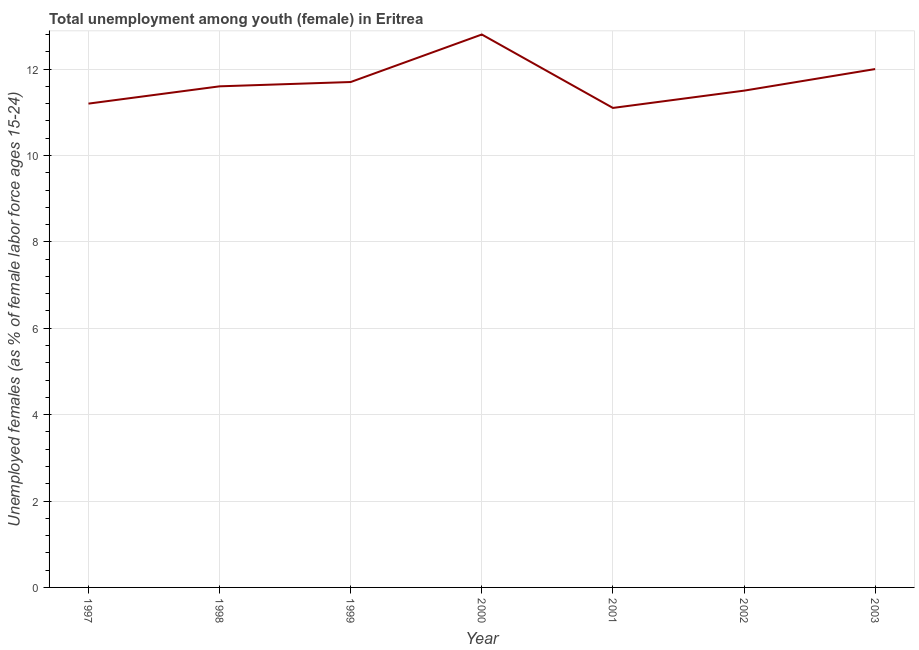What is the unemployed female youth population in 1999?
Keep it short and to the point. 11.7. Across all years, what is the maximum unemployed female youth population?
Keep it short and to the point. 12.8. Across all years, what is the minimum unemployed female youth population?
Keep it short and to the point. 11.1. In which year was the unemployed female youth population maximum?
Keep it short and to the point. 2000. In which year was the unemployed female youth population minimum?
Your response must be concise. 2001. What is the sum of the unemployed female youth population?
Offer a very short reply. 81.9. What is the difference between the unemployed female youth population in 2000 and 2003?
Your answer should be very brief. 0.8. What is the average unemployed female youth population per year?
Ensure brevity in your answer.  11.7. What is the median unemployed female youth population?
Provide a short and direct response. 11.6. In how many years, is the unemployed female youth population greater than 4 %?
Your answer should be very brief. 7. What is the ratio of the unemployed female youth population in 2000 to that in 2001?
Provide a succinct answer. 1.15. Is the unemployed female youth population in 2000 less than that in 2003?
Provide a succinct answer. No. What is the difference between the highest and the second highest unemployed female youth population?
Your answer should be very brief. 0.8. What is the difference between the highest and the lowest unemployed female youth population?
Offer a terse response. 1.7. In how many years, is the unemployed female youth population greater than the average unemployed female youth population taken over all years?
Provide a short and direct response. 2. Does the unemployed female youth population monotonically increase over the years?
Keep it short and to the point. No. How many lines are there?
Provide a short and direct response. 1. How many years are there in the graph?
Make the answer very short. 7. What is the difference between two consecutive major ticks on the Y-axis?
Make the answer very short. 2. Does the graph contain any zero values?
Your answer should be very brief. No. Does the graph contain grids?
Make the answer very short. Yes. What is the title of the graph?
Your response must be concise. Total unemployment among youth (female) in Eritrea. What is the label or title of the X-axis?
Ensure brevity in your answer.  Year. What is the label or title of the Y-axis?
Give a very brief answer. Unemployed females (as % of female labor force ages 15-24). What is the Unemployed females (as % of female labor force ages 15-24) of 1997?
Give a very brief answer. 11.2. What is the Unemployed females (as % of female labor force ages 15-24) of 1998?
Your response must be concise. 11.6. What is the Unemployed females (as % of female labor force ages 15-24) in 1999?
Provide a succinct answer. 11.7. What is the Unemployed females (as % of female labor force ages 15-24) in 2000?
Offer a terse response. 12.8. What is the Unemployed females (as % of female labor force ages 15-24) in 2001?
Give a very brief answer. 11.1. What is the difference between the Unemployed females (as % of female labor force ages 15-24) in 1997 and 1998?
Offer a very short reply. -0.4. What is the difference between the Unemployed females (as % of female labor force ages 15-24) in 1997 and 1999?
Give a very brief answer. -0.5. What is the difference between the Unemployed females (as % of female labor force ages 15-24) in 1997 and 2000?
Your answer should be compact. -1.6. What is the difference between the Unemployed females (as % of female labor force ages 15-24) in 1997 and 2002?
Give a very brief answer. -0.3. What is the difference between the Unemployed females (as % of female labor force ages 15-24) in 1997 and 2003?
Give a very brief answer. -0.8. What is the difference between the Unemployed females (as % of female labor force ages 15-24) in 1998 and 1999?
Your answer should be very brief. -0.1. What is the difference between the Unemployed females (as % of female labor force ages 15-24) in 1998 and 2000?
Make the answer very short. -1.2. What is the difference between the Unemployed females (as % of female labor force ages 15-24) in 1998 and 2001?
Provide a succinct answer. 0.5. What is the difference between the Unemployed females (as % of female labor force ages 15-24) in 1998 and 2002?
Make the answer very short. 0.1. What is the difference between the Unemployed females (as % of female labor force ages 15-24) in 1999 and 2001?
Your answer should be compact. 0.6. What is the difference between the Unemployed females (as % of female labor force ages 15-24) in 1999 and 2003?
Offer a very short reply. -0.3. What is the difference between the Unemployed females (as % of female labor force ages 15-24) in 2000 and 2002?
Your answer should be compact. 1.3. What is the difference between the Unemployed females (as % of female labor force ages 15-24) in 2000 and 2003?
Offer a very short reply. 0.8. What is the ratio of the Unemployed females (as % of female labor force ages 15-24) in 1997 to that in 1999?
Make the answer very short. 0.96. What is the ratio of the Unemployed females (as % of female labor force ages 15-24) in 1997 to that in 2001?
Ensure brevity in your answer.  1.01. What is the ratio of the Unemployed females (as % of female labor force ages 15-24) in 1997 to that in 2002?
Your response must be concise. 0.97. What is the ratio of the Unemployed females (as % of female labor force ages 15-24) in 1997 to that in 2003?
Make the answer very short. 0.93. What is the ratio of the Unemployed females (as % of female labor force ages 15-24) in 1998 to that in 2000?
Provide a succinct answer. 0.91. What is the ratio of the Unemployed females (as % of female labor force ages 15-24) in 1998 to that in 2001?
Make the answer very short. 1.04. What is the ratio of the Unemployed females (as % of female labor force ages 15-24) in 1998 to that in 2003?
Your answer should be very brief. 0.97. What is the ratio of the Unemployed females (as % of female labor force ages 15-24) in 1999 to that in 2000?
Make the answer very short. 0.91. What is the ratio of the Unemployed females (as % of female labor force ages 15-24) in 1999 to that in 2001?
Offer a terse response. 1.05. What is the ratio of the Unemployed females (as % of female labor force ages 15-24) in 2000 to that in 2001?
Provide a short and direct response. 1.15. What is the ratio of the Unemployed females (as % of female labor force ages 15-24) in 2000 to that in 2002?
Your answer should be compact. 1.11. What is the ratio of the Unemployed females (as % of female labor force ages 15-24) in 2000 to that in 2003?
Your answer should be compact. 1.07. What is the ratio of the Unemployed females (as % of female labor force ages 15-24) in 2001 to that in 2003?
Ensure brevity in your answer.  0.93. What is the ratio of the Unemployed females (as % of female labor force ages 15-24) in 2002 to that in 2003?
Your answer should be compact. 0.96. 